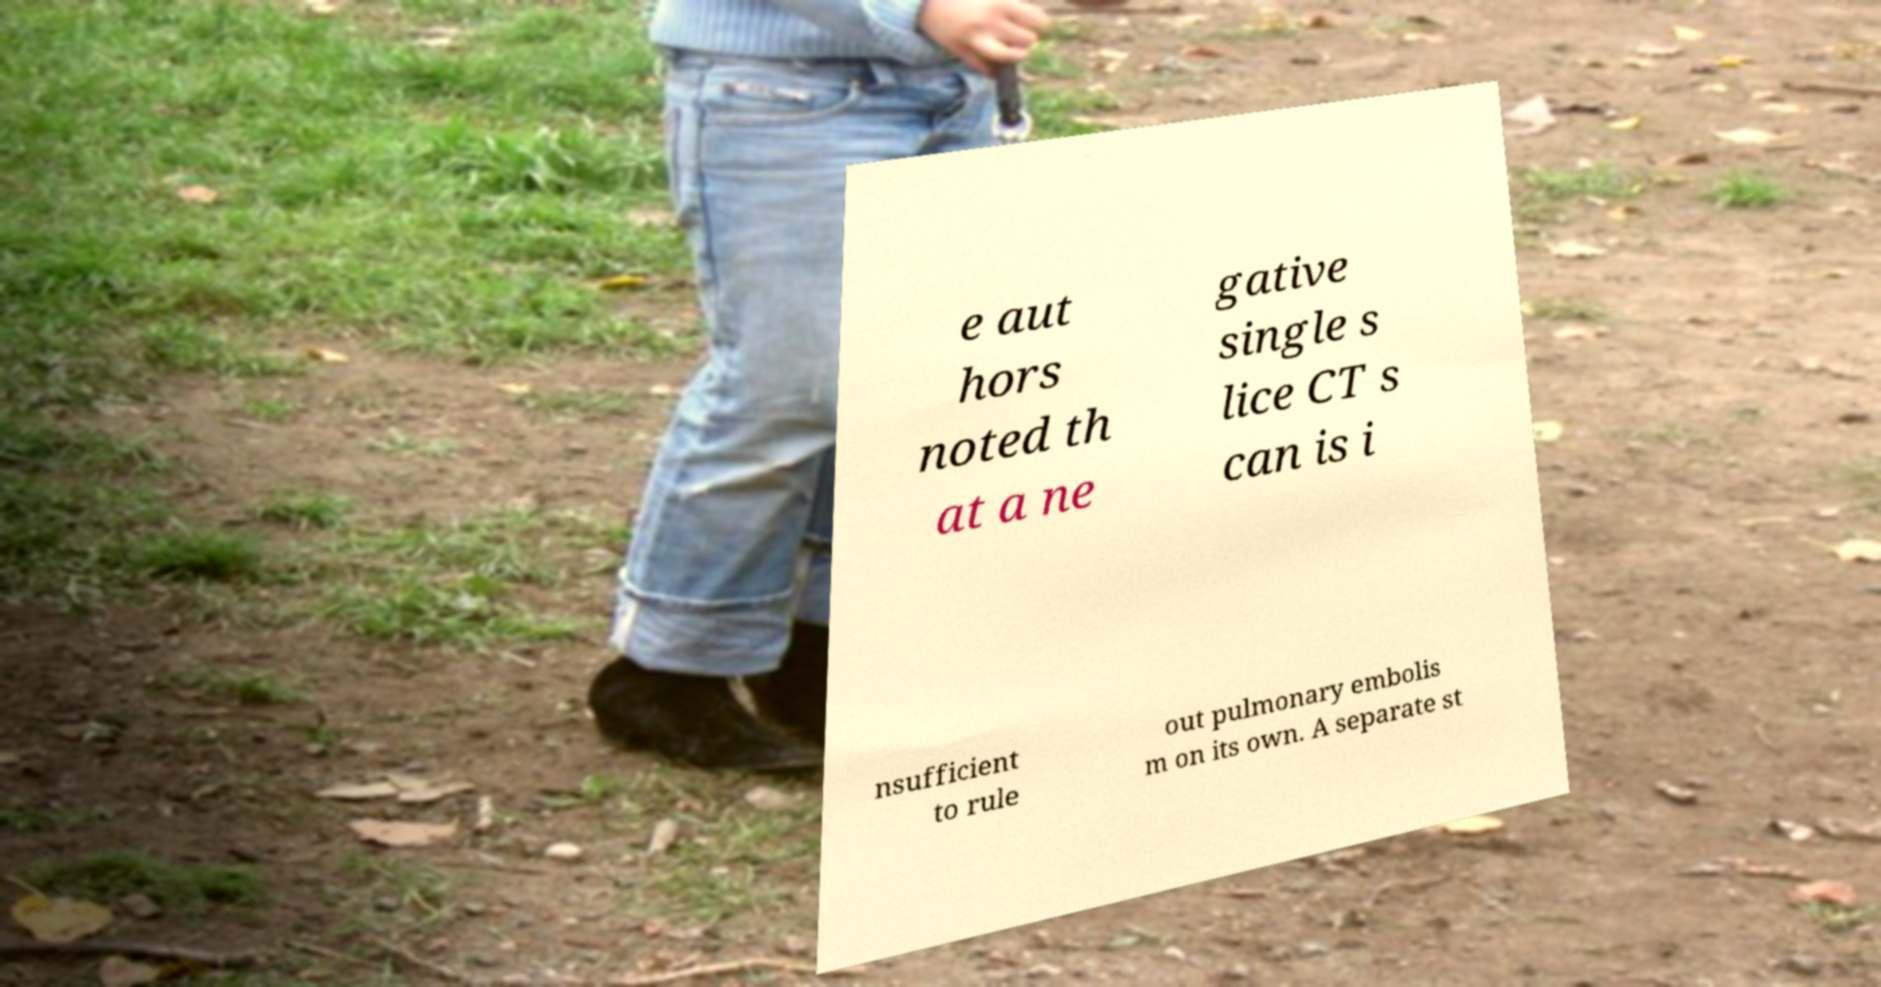There's text embedded in this image that I need extracted. Can you transcribe it verbatim? e aut hors noted th at a ne gative single s lice CT s can is i nsufficient to rule out pulmonary embolis m on its own. A separate st 